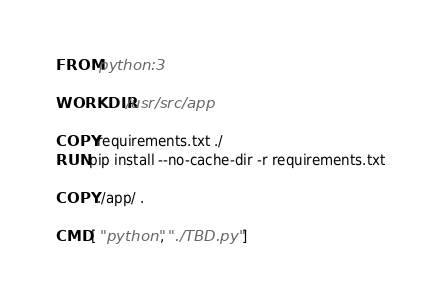Convert code to text. <code><loc_0><loc_0><loc_500><loc_500><_Dockerfile_>FROM python:3

WORKDIR /usr/src/app

COPY requirements.txt ./
RUN pip install --no-cache-dir -r requirements.txt

COPY ./app/ .

CMD [ "python", "./TBD.py" ]
</code> 